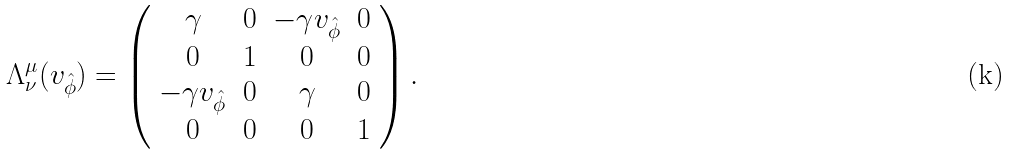<formula> <loc_0><loc_0><loc_500><loc_500>\Lambda ^ { \mu } _ { \nu } ( v _ { \hat { \phi } } ) = \left ( \begin{array} { c c c c } \gamma & 0 & - \gamma v _ { \hat { \phi } } & 0 \\ 0 & 1 & 0 & 0 \\ - \gamma v _ { \hat { \phi } } & 0 & \gamma & 0 \\ 0 & 0 & 0 & 1 \\ \end{array} \right ) .</formula> 